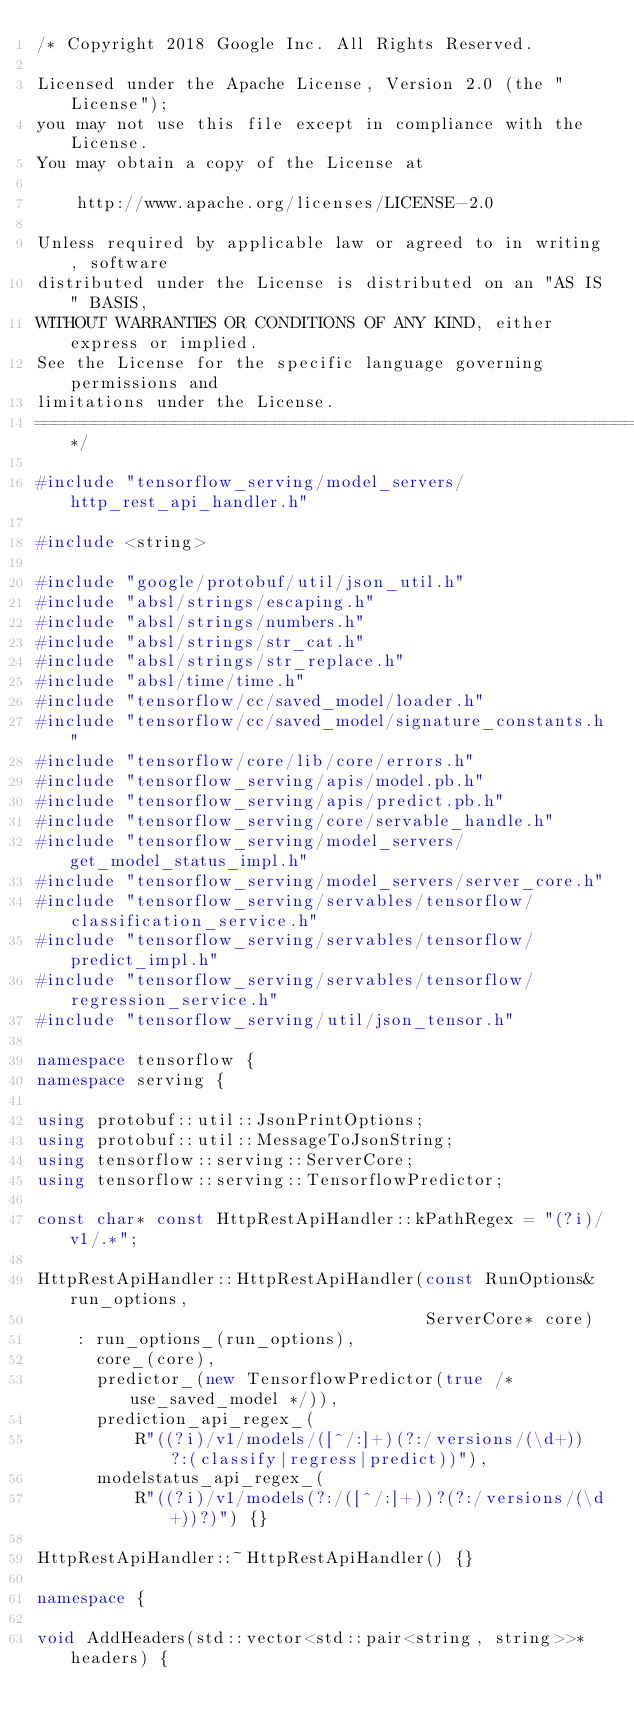<code> <loc_0><loc_0><loc_500><loc_500><_C++_>/* Copyright 2018 Google Inc. All Rights Reserved.

Licensed under the Apache License, Version 2.0 (the "License");
you may not use this file except in compliance with the License.
You may obtain a copy of the License at

    http://www.apache.org/licenses/LICENSE-2.0

Unless required by applicable law or agreed to in writing, software
distributed under the License is distributed on an "AS IS" BASIS,
WITHOUT WARRANTIES OR CONDITIONS OF ANY KIND, either express or implied.
See the License for the specific language governing permissions and
limitations under the License.
==============================================================================*/

#include "tensorflow_serving/model_servers/http_rest_api_handler.h"

#include <string>

#include "google/protobuf/util/json_util.h"
#include "absl/strings/escaping.h"
#include "absl/strings/numbers.h"
#include "absl/strings/str_cat.h"
#include "absl/strings/str_replace.h"
#include "absl/time/time.h"
#include "tensorflow/cc/saved_model/loader.h"
#include "tensorflow/cc/saved_model/signature_constants.h"
#include "tensorflow/core/lib/core/errors.h"
#include "tensorflow_serving/apis/model.pb.h"
#include "tensorflow_serving/apis/predict.pb.h"
#include "tensorflow_serving/core/servable_handle.h"
#include "tensorflow_serving/model_servers/get_model_status_impl.h"
#include "tensorflow_serving/model_servers/server_core.h"
#include "tensorflow_serving/servables/tensorflow/classification_service.h"
#include "tensorflow_serving/servables/tensorflow/predict_impl.h"
#include "tensorflow_serving/servables/tensorflow/regression_service.h"
#include "tensorflow_serving/util/json_tensor.h"

namespace tensorflow {
namespace serving {

using protobuf::util::JsonPrintOptions;
using protobuf::util::MessageToJsonString;
using tensorflow::serving::ServerCore;
using tensorflow::serving::TensorflowPredictor;

const char* const HttpRestApiHandler::kPathRegex = "(?i)/v1/.*";

HttpRestApiHandler::HttpRestApiHandler(const RunOptions& run_options,
                                       ServerCore* core)
    : run_options_(run_options),
      core_(core),
      predictor_(new TensorflowPredictor(true /* use_saved_model */)),
      prediction_api_regex_(
          R"((?i)/v1/models/([^/:]+)(?:/versions/(\d+))?:(classify|regress|predict))"),
      modelstatus_api_regex_(
          R"((?i)/v1/models(?:/([^/:]+))?(?:/versions/(\d+))?)") {}

HttpRestApiHandler::~HttpRestApiHandler() {}

namespace {

void AddHeaders(std::vector<std::pair<string, string>>* headers) {</code> 